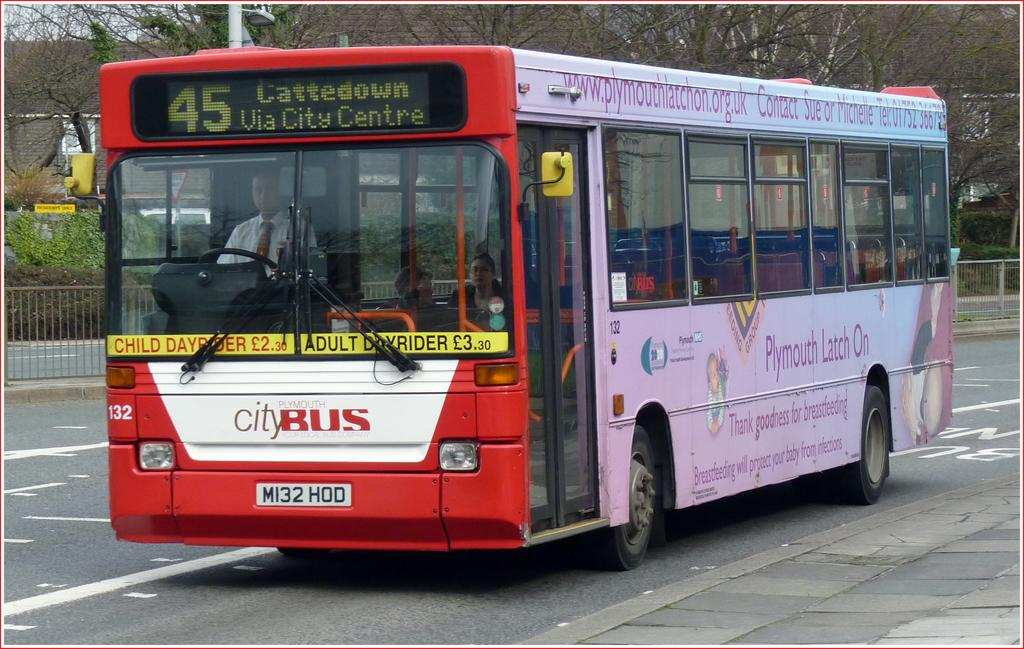Provide a one-sentence caption for the provided image. City bus driving on the road colored red, white and pink. 